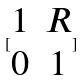<formula> <loc_0><loc_0><loc_500><loc_500>[ \begin{matrix} 1 & R \\ 0 & 1 \end{matrix} ]</formula> 